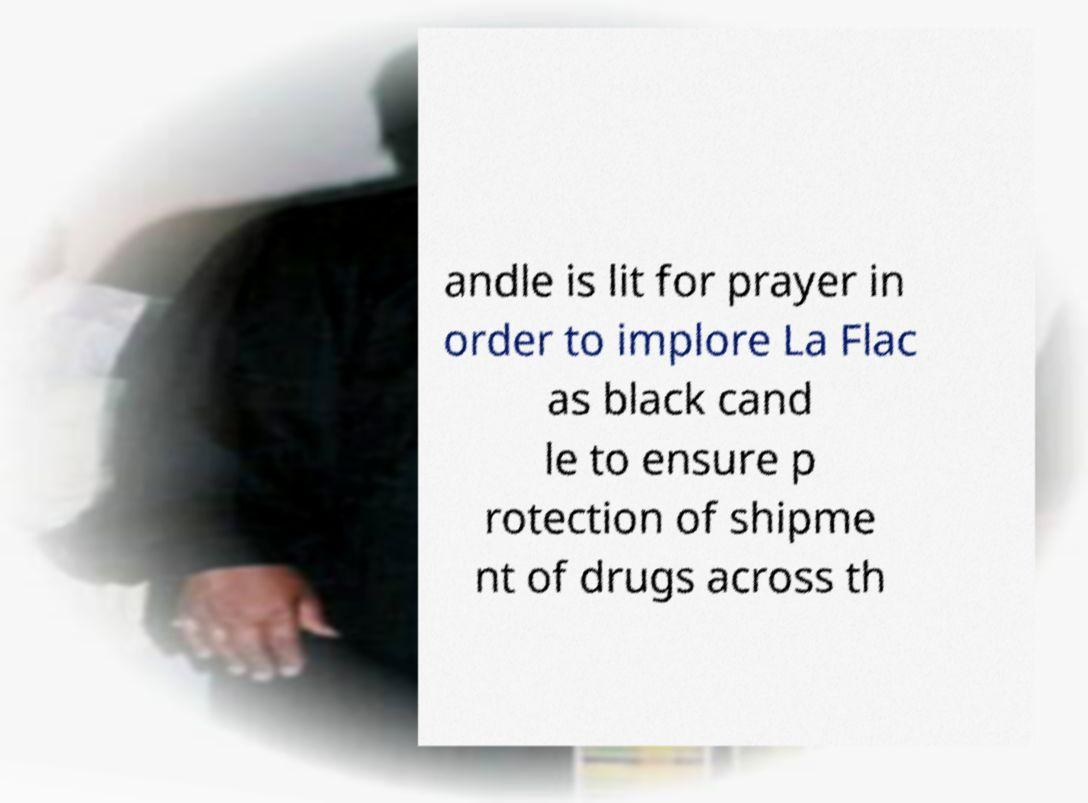Could you extract and type out the text from this image? andle is lit for prayer in order to implore La Flac as black cand le to ensure p rotection of shipme nt of drugs across th 